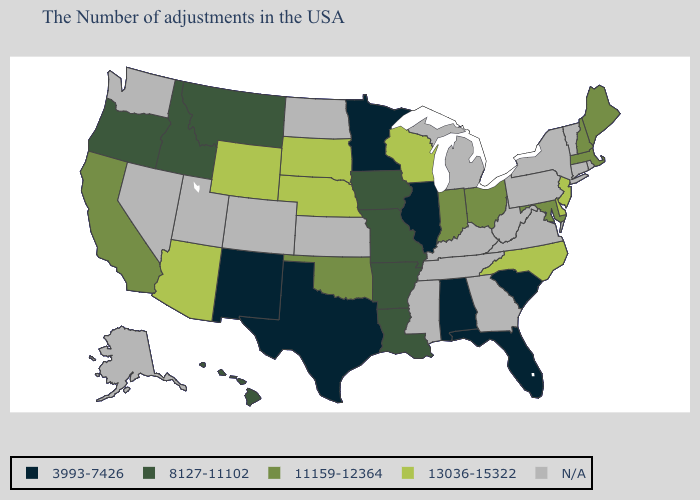What is the value of Illinois?
Concise answer only. 3993-7426. Name the states that have a value in the range 13036-15322?
Answer briefly. New Jersey, Delaware, North Carolina, Wisconsin, Nebraska, South Dakota, Wyoming, Arizona. Is the legend a continuous bar?
Give a very brief answer. No. Name the states that have a value in the range N/A?
Give a very brief answer. Rhode Island, Vermont, Connecticut, New York, Pennsylvania, Virginia, West Virginia, Georgia, Michigan, Kentucky, Tennessee, Mississippi, Kansas, North Dakota, Colorado, Utah, Nevada, Washington, Alaska. Name the states that have a value in the range N/A?
Concise answer only. Rhode Island, Vermont, Connecticut, New York, Pennsylvania, Virginia, West Virginia, Georgia, Michigan, Kentucky, Tennessee, Mississippi, Kansas, North Dakota, Colorado, Utah, Nevada, Washington, Alaska. Name the states that have a value in the range 11159-12364?
Give a very brief answer. Maine, Massachusetts, New Hampshire, Maryland, Ohio, Indiana, Oklahoma, California. What is the highest value in the South ?
Short answer required. 13036-15322. Does Delaware have the highest value in the USA?
Short answer required. Yes. Among the states that border Georgia , does Alabama have the highest value?
Keep it brief. No. Is the legend a continuous bar?
Be succinct. No. Name the states that have a value in the range 8127-11102?
Be succinct. Louisiana, Missouri, Arkansas, Iowa, Montana, Idaho, Oregon, Hawaii. Name the states that have a value in the range N/A?
Concise answer only. Rhode Island, Vermont, Connecticut, New York, Pennsylvania, Virginia, West Virginia, Georgia, Michigan, Kentucky, Tennessee, Mississippi, Kansas, North Dakota, Colorado, Utah, Nevada, Washington, Alaska. Among the states that border Connecticut , which have the lowest value?
Give a very brief answer. Massachusetts. Name the states that have a value in the range 13036-15322?
Write a very short answer. New Jersey, Delaware, North Carolina, Wisconsin, Nebraska, South Dakota, Wyoming, Arizona. 